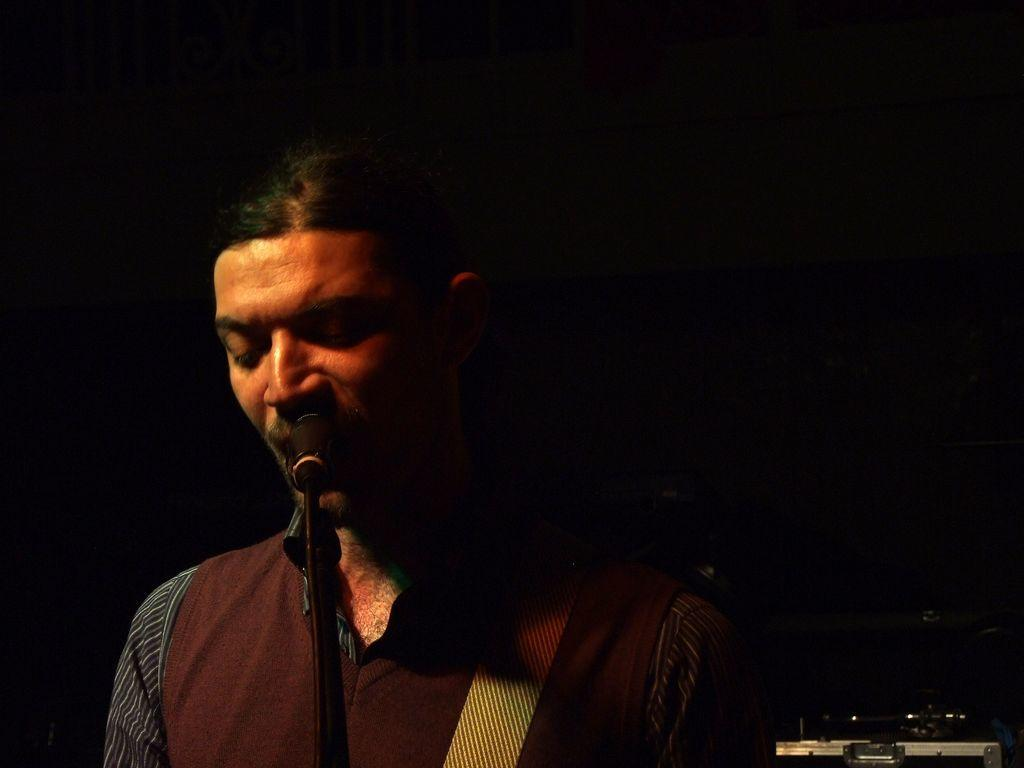Who is the main subject in the foreground of the image? There is a man in the foreground of the image. What is the man doing in the image? The man is standing in front of a mic. How would you describe the lighting in the image? The scene is dark. What can be seen at the bottom of the image? There is an object at the bottom of the image. What type of letters are being discussed in the meeting in the image? There is no meeting present in the image, and therefore no discussion of letters can be observed. 